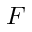Convert formula to latex. <formula><loc_0><loc_0><loc_500><loc_500>F</formula> 